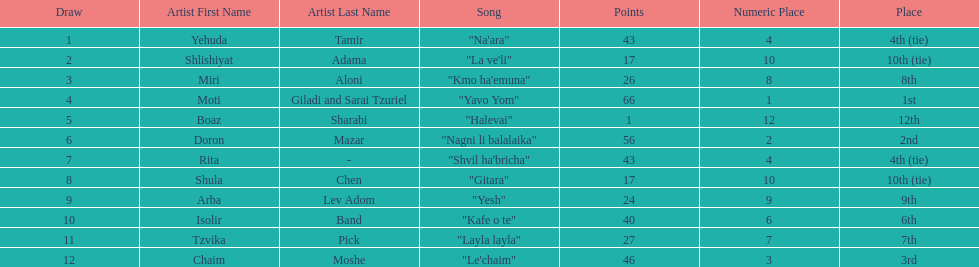How many points does the artist rita have? 43. 